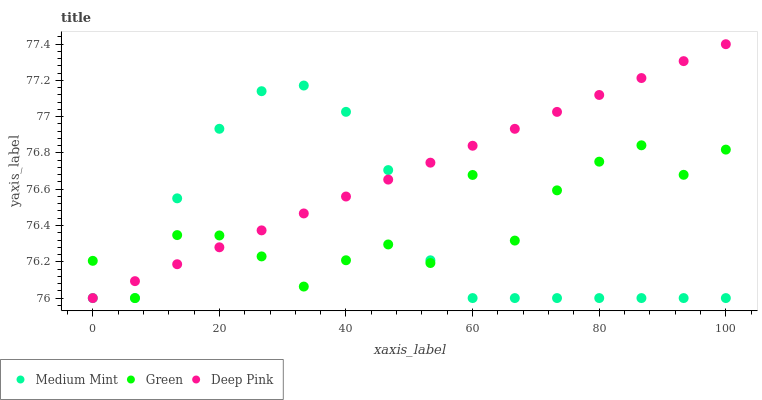Does Medium Mint have the minimum area under the curve?
Answer yes or no. Yes. Does Deep Pink have the maximum area under the curve?
Answer yes or no. Yes. Does Green have the minimum area under the curve?
Answer yes or no. No. Does Green have the maximum area under the curve?
Answer yes or no. No. Is Deep Pink the smoothest?
Answer yes or no. Yes. Is Green the roughest?
Answer yes or no. Yes. Is Green the smoothest?
Answer yes or no. No. Is Deep Pink the roughest?
Answer yes or no. No. Does Medium Mint have the lowest value?
Answer yes or no. Yes. Does Deep Pink have the highest value?
Answer yes or no. Yes. Does Green have the highest value?
Answer yes or no. No. Does Green intersect Deep Pink?
Answer yes or no. Yes. Is Green less than Deep Pink?
Answer yes or no. No. Is Green greater than Deep Pink?
Answer yes or no. No. 